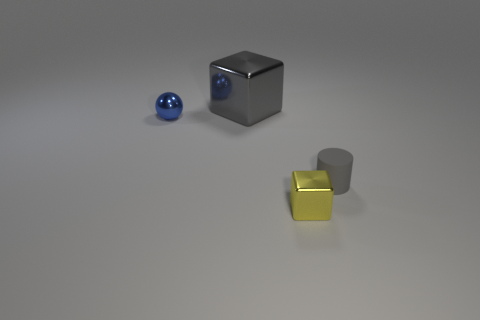Add 4 big gray metallic balls. How many objects exist? 8 Subtract all yellow blocks. How many blocks are left? 1 Subtract all spheres. How many objects are left? 3 Subtract all cyan cylinders. Subtract all cyan blocks. How many cylinders are left? 1 Subtract all cyan spheres. How many gray cubes are left? 1 Subtract all large gray things. Subtract all gray matte cylinders. How many objects are left? 2 Add 4 small metallic objects. How many small metallic objects are left? 6 Add 4 large green matte blocks. How many large green matte blocks exist? 4 Subtract 1 gray cubes. How many objects are left? 3 Subtract 1 cylinders. How many cylinders are left? 0 